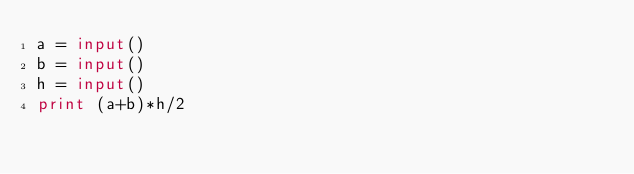<code> <loc_0><loc_0><loc_500><loc_500><_Python_>a = input()
b = input()
h = input()
print (a+b)*h/2</code> 